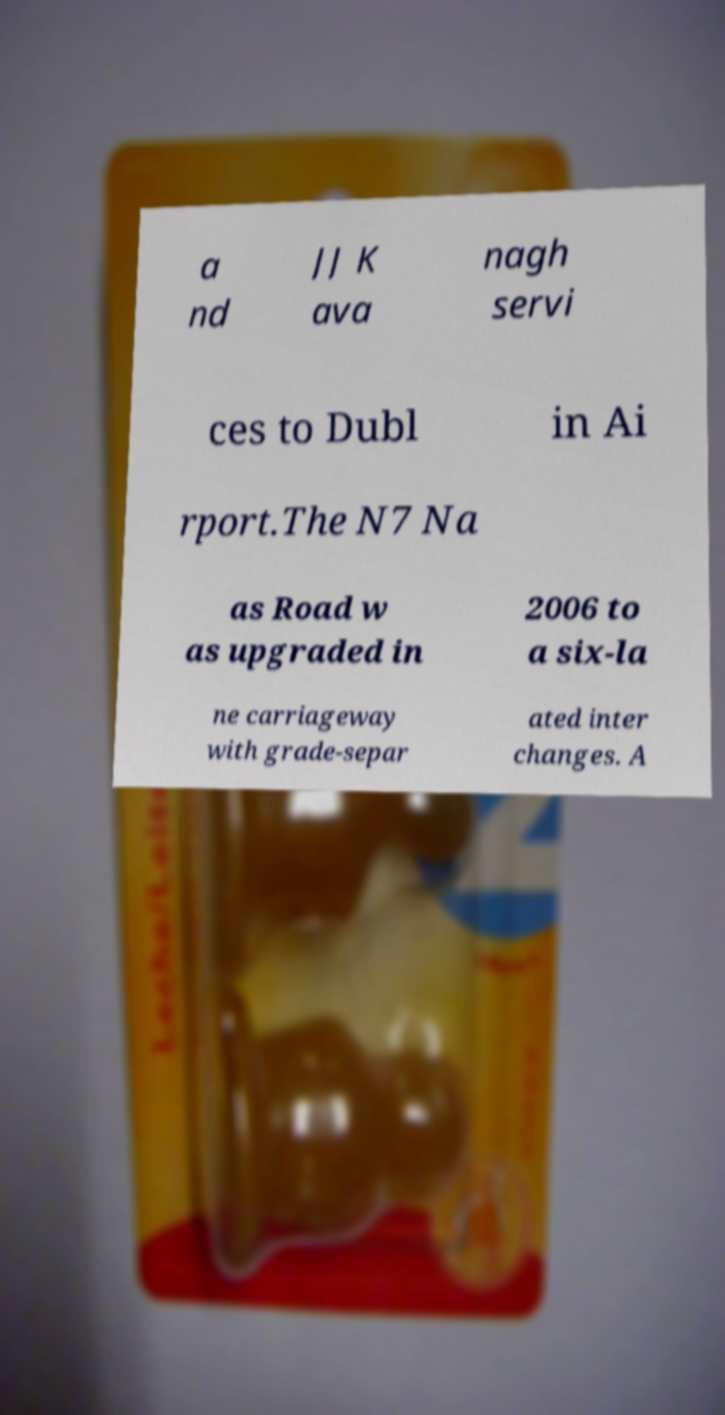Could you extract and type out the text from this image? a nd JJ K ava nagh servi ces to Dubl in Ai rport.The N7 Na as Road w as upgraded in 2006 to a six-la ne carriageway with grade-separ ated inter changes. A 